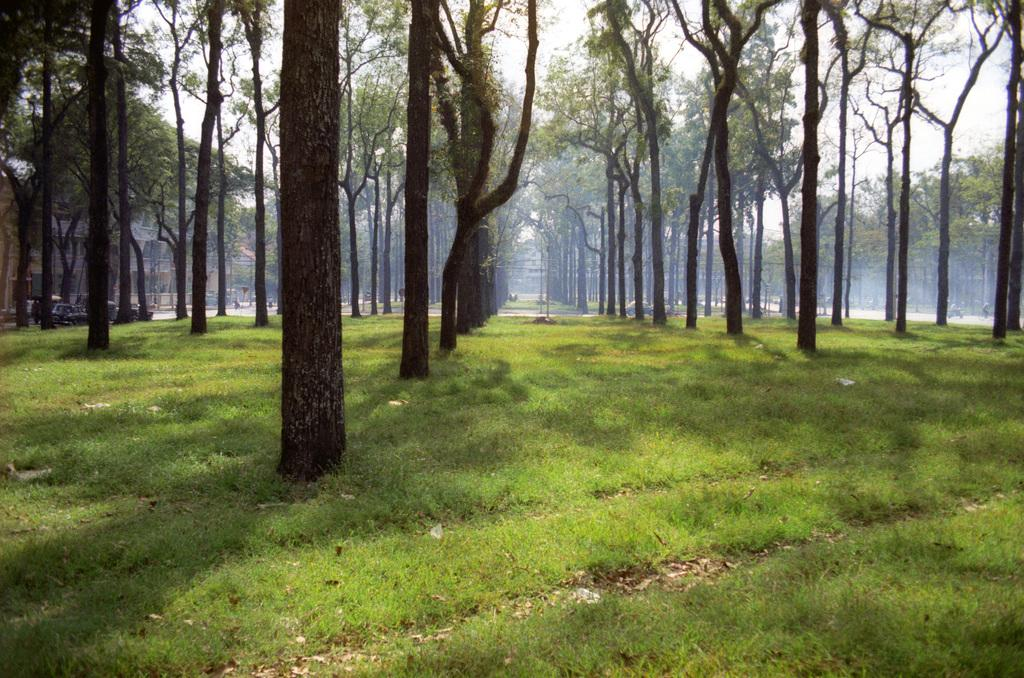What type of vegetation covers the land in the image? The land is covered with grass. What other natural elements can be seen in the image? There are trees in the image. What can be seen in the distance in the image? There are vehicles and at least one building visible in the distance. What type of frog can be seen taking care of the grass in the image? There is no frog present in the image, and the grass does not require care in the context of the image. 